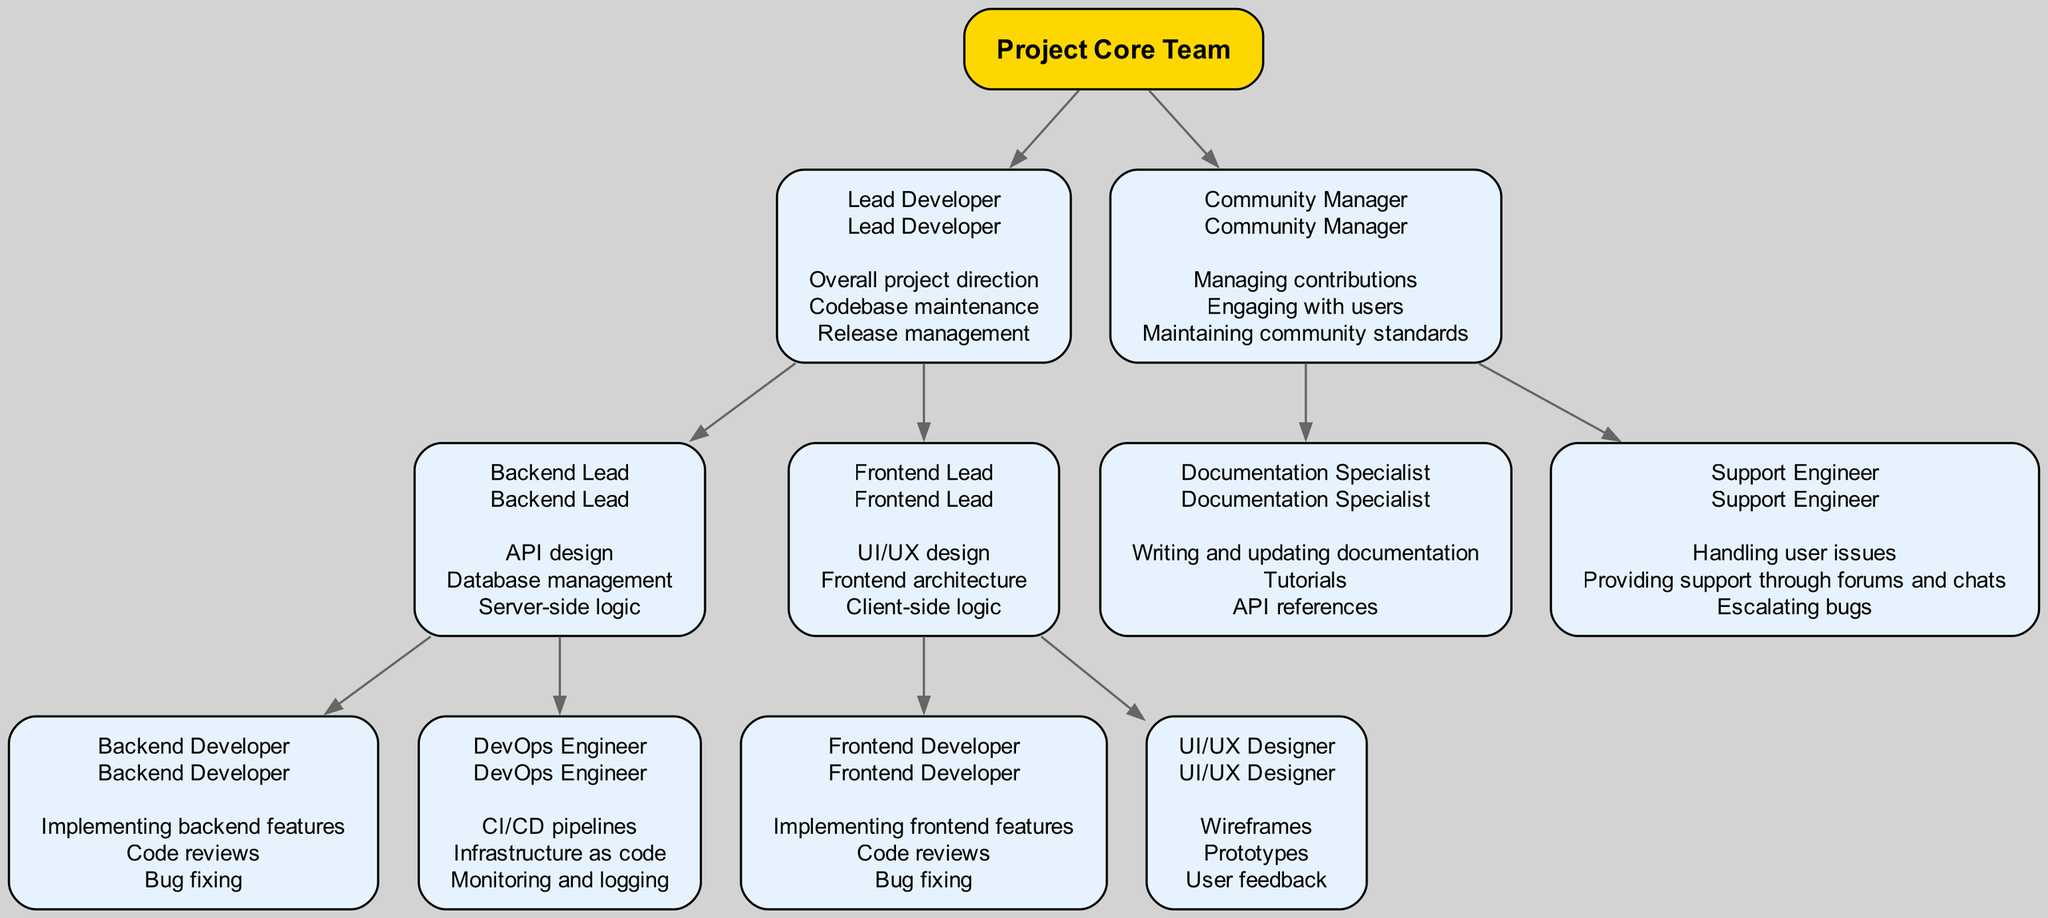What is the top-level role in the diagram? The top-level role is clearly labeled as "Project Core Team," which represents the overarching structure of the development team.
Answer: Project Core Team How many members report directly to the Lead Developer? The Lead Developer has two direct reports: the Backend Lead and the Frontend Lead, as shown in the diagram under their respective node connections.
Answer: 2 Who is responsible for API design? The role responsible for API design is represented by the Backend Lead, indicated by their responsibilities listed under their node.
Answer: Backend Lead What are the responsibilities of the Community Manager? The responsibilities of the Community Manager include managing contributions, engaging with users, and maintaining community standards, all of which are listed clearly in the diagram.
Answer: Managing contributions, engaging with users, maintaining community standards How many subordinates does the Frontend Lead have? The Frontend Lead oversees two subordinates: the Frontend Developer and the UI/UX Designer, as represented in their node and the connections in the diagram.
Answer: 2 Which role directly handles user issues? The Support Engineer is depicted as the role that handles user issues, explicitly mentioned under their responsibilities in the diagram.
Answer: Support Engineer What is the main task of the Documentation Specialist? According to the diagram, the main task of the Documentation Specialist involves writing and updating documentation, shown in the responsibilities listed next to their node.
Answer: Writing and updating documentation What color is used for the root node in the diagram? The root node is highlighted in a golden yellow color, which differentiates it from the other nodes in the diagram.
Answer: Gold Which position is responsible for CI/CD pipelines? The CI/CD pipelines are the responsibility of the DevOps Engineer, as this specific task is listed under their responsibilities in the hierarchy.
Answer: DevOps Engineer 